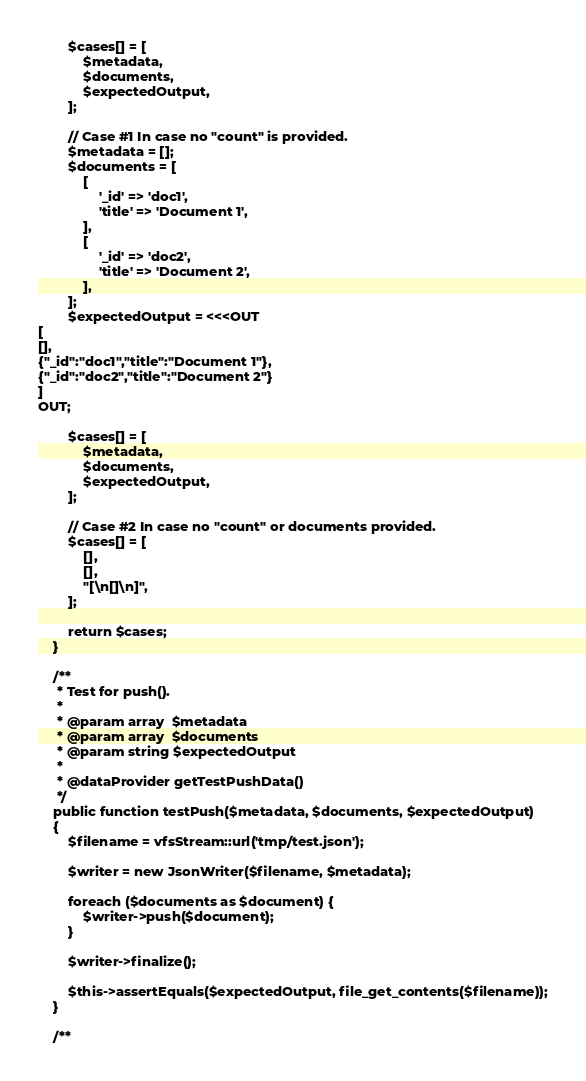<code> <loc_0><loc_0><loc_500><loc_500><_PHP_>
        $cases[] = [
            $metadata,
            $documents,
            $expectedOutput,
        ];

        // Case #1 In case no "count" is provided.
        $metadata = [];
        $documents = [
            [
                '_id' => 'doc1',
                'title' => 'Document 1',
            ],
            [
                '_id' => 'doc2',
                'title' => 'Document 2',
            ],
        ];
        $expectedOutput = <<<OUT
[
[],
{"_id":"doc1","title":"Document 1"},
{"_id":"doc2","title":"Document 2"}
]
OUT;

        $cases[] = [
            $metadata,
            $documents,
            $expectedOutput,
        ];

        // Case #2 In case no "count" or documents provided.
        $cases[] = [
            [],
            [],
            "[\n[]\n]",
        ];

        return $cases;
    }

    /**
     * Test for push().
     *
     * @param array  $metadata
     * @param array  $documents
     * @param string $expectedOutput
     *
     * @dataProvider getTestPushData()
     */
    public function testPush($metadata, $documents, $expectedOutput)
    {
        $filename = vfsStream::url('tmp/test.json');

        $writer = new JsonWriter($filename, $metadata);

        foreach ($documents as $document) {
            $writer->push($document);
        }

        $writer->finalize();

        $this->assertEquals($expectedOutput, file_get_contents($filename));
    }

    /**</code> 